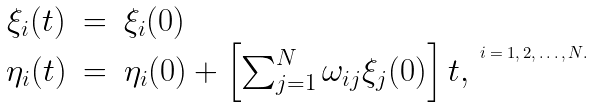Convert formula to latex. <formula><loc_0><loc_0><loc_500><loc_500>\begin{array} { c c l } \xi _ { i } ( t ) & = & \xi _ { i } ( 0 ) \\ \eta _ { i } ( t ) & = & \eta _ { i } ( 0 ) + \left [ \sum _ { j = 1 } ^ { N } \omega _ { i j } \xi _ { j } ( 0 ) \right ] t , \end{array} \, i = 1 , 2 , \dots , N .</formula> 